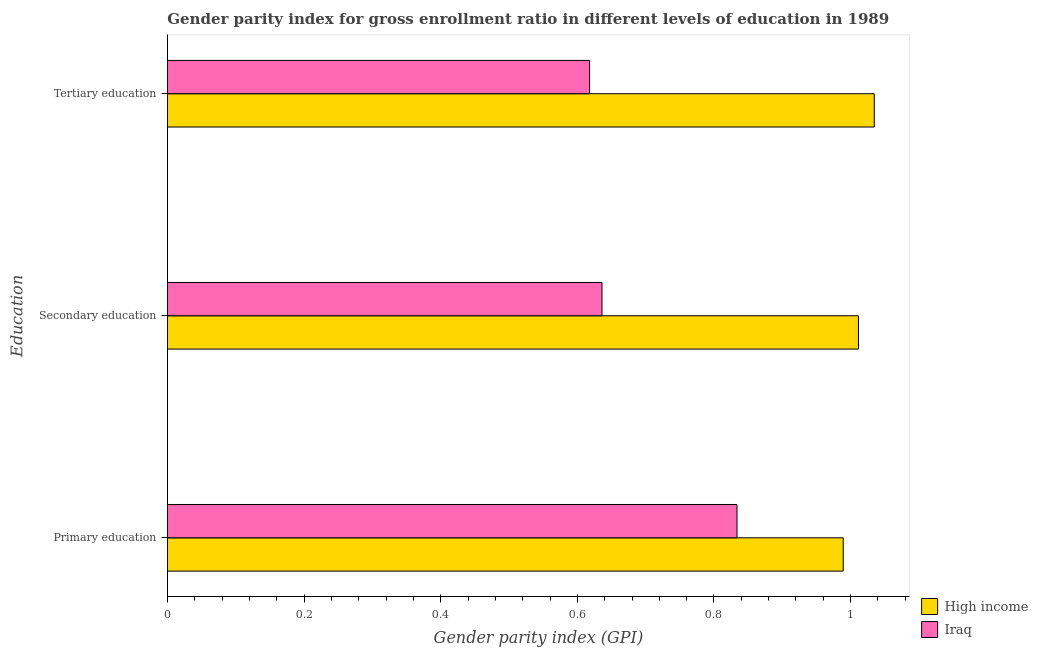How many different coloured bars are there?
Provide a succinct answer. 2. Are the number of bars per tick equal to the number of legend labels?
Offer a very short reply. Yes. How many bars are there on the 3rd tick from the top?
Your answer should be compact. 2. What is the label of the 2nd group of bars from the top?
Your answer should be very brief. Secondary education. What is the gender parity index in tertiary education in High income?
Your response must be concise. 1.03. Across all countries, what is the maximum gender parity index in tertiary education?
Ensure brevity in your answer.  1.03. Across all countries, what is the minimum gender parity index in secondary education?
Make the answer very short. 0.64. In which country was the gender parity index in tertiary education maximum?
Your answer should be very brief. High income. In which country was the gender parity index in tertiary education minimum?
Make the answer very short. Iraq. What is the total gender parity index in primary education in the graph?
Provide a succinct answer. 1.82. What is the difference between the gender parity index in tertiary education in Iraq and that in High income?
Offer a terse response. -0.42. What is the difference between the gender parity index in secondary education in Iraq and the gender parity index in tertiary education in High income?
Offer a terse response. -0.4. What is the average gender parity index in secondary education per country?
Offer a terse response. 0.82. What is the difference between the gender parity index in secondary education and gender parity index in primary education in Iraq?
Ensure brevity in your answer.  -0.2. What is the ratio of the gender parity index in tertiary education in Iraq to that in High income?
Your response must be concise. 0.6. Is the difference between the gender parity index in primary education in High income and Iraq greater than the difference between the gender parity index in tertiary education in High income and Iraq?
Give a very brief answer. No. What is the difference between the highest and the second highest gender parity index in tertiary education?
Offer a very short reply. 0.42. What is the difference between the highest and the lowest gender parity index in primary education?
Your response must be concise. 0.16. Is the sum of the gender parity index in secondary education in High income and Iraq greater than the maximum gender parity index in primary education across all countries?
Make the answer very short. Yes. What does the 1st bar from the top in Primary education represents?
Make the answer very short. Iraq. Are all the bars in the graph horizontal?
Keep it short and to the point. Yes. How many countries are there in the graph?
Give a very brief answer. 2. Does the graph contain any zero values?
Your response must be concise. No. How many legend labels are there?
Offer a terse response. 2. How are the legend labels stacked?
Make the answer very short. Vertical. What is the title of the graph?
Give a very brief answer. Gender parity index for gross enrollment ratio in different levels of education in 1989. What is the label or title of the X-axis?
Offer a terse response. Gender parity index (GPI). What is the label or title of the Y-axis?
Provide a short and direct response. Education. What is the Gender parity index (GPI) in High income in Primary education?
Your answer should be very brief. 0.99. What is the Gender parity index (GPI) of Iraq in Primary education?
Offer a terse response. 0.83. What is the Gender parity index (GPI) in High income in Secondary education?
Provide a succinct answer. 1.01. What is the Gender parity index (GPI) in Iraq in Secondary education?
Ensure brevity in your answer.  0.64. What is the Gender parity index (GPI) of High income in Tertiary education?
Ensure brevity in your answer.  1.03. What is the Gender parity index (GPI) of Iraq in Tertiary education?
Keep it short and to the point. 0.62. Across all Education, what is the maximum Gender parity index (GPI) of High income?
Offer a very short reply. 1.03. Across all Education, what is the maximum Gender parity index (GPI) in Iraq?
Provide a short and direct response. 0.83. Across all Education, what is the minimum Gender parity index (GPI) in High income?
Your answer should be compact. 0.99. Across all Education, what is the minimum Gender parity index (GPI) of Iraq?
Your answer should be compact. 0.62. What is the total Gender parity index (GPI) of High income in the graph?
Provide a succinct answer. 3.04. What is the total Gender parity index (GPI) of Iraq in the graph?
Your response must be concise. 2.09. What is the difference between the Gender parity index (GPI) of High income in Primary education and that in Secondary education?
Offer a terse response. -0.02. What is the difference between the Gender parity index (GPI) in Iraq in Primary education and that in Secondary education?
Provide a succinct answer. 0.2. What is the difference between the Gender parity index (GPI) of High income in Primary education and that in Tertiary education?
Offer a terse response. -0.05. What is the difference between the Gender parity index (GPI) in Iraq in Primary education and that in Tertiary education?
Offer a very short reply. 0.22. What is the difference between the Gender parity index (GPI) in High income in Secondary education and that in Tertiary education?
Give a very brief answer. -0.02. What is the difference between the Gender parity index (GPI) of Iraq in Secondary education and that in Tertiary education?
Your answer should be very brief. 0.02. What is the difference between the Gender parity index (GPI) of High income in Primary education and the Gender parity index (GPI) of Iraq in Secondary education?
Ensure brevity in your answer.  0.35. What is the difference between the Gender parity index (GPI) in High income in Primary education and the Gender parity index (GPI) in Iraq in Tertiary education?
Provide a short and direct response. 0.37. What is the difference between the Gender parity index (GPI) of High income in Secondary education and the Gender parity index (GPI) of Iraq in Tertiary education?
Provide a short and direct response. 0.39. What is the average Gender parity index (GPI) in High income per Education?
Provide a succinct answer. 1.01. What is the average Gender parity index (GPI) in Iraq per Education?
Make the answer very short. 0.7. What is the difference between the Gender parity index (GPI) of High income and Gender parity index (GPI) of Iraq in Primary education?
Make the answer very short. 0.16. What is the difference between the Gender parity index (GPI) of High income and Gender parity index (GPI) of Iraq in Secondary education?
Keep it short and to the point. 0.38. What is the difference between the Gender parity index (GPI) of High income and Gender parity index (GPI) of Iraq in Tertiary education?
Your answer should be compact. 0.42. What is the ratio of the Gender parity index (GPI) in High income in Primary education to that in Secondary education?
Ensure brevity in your answer.  0.98. What is the ratio of the Gender parity index (GPI) of Iraq in Primary education to that in Secondary education?
Your answer should be very brief. 1.31. What is the ratio of the Gender parity index (GPI) of High income in Primary education to that in Tertiary education?
Your response must be concise. 0.96. What is the ratio of the Gender parity index (GPI) of Iraq in Primary education to that in Tertiary education?
Offer a terse response. 1.35. What is the ratio of the Gender parity index (GPI) in High income in Secondary education to that in Tertiary education?
Your answer should be compact. 0.98. What is the ratio of the Gender parity index (GPI) of Iraq in Secondary education to that in Tertiary education?
Provide a succinct answer. 1.03. What is the difference between the highest and the second highest Gender parity index (GPI) in High income?
Make the answer very short. 0.02. What is the difference between the highest and the second highest Gender parity index (GPI) of Iraq?
Ensure brevity in your answer.  0.2. What is the difference between the highest and the lowest Gender parity index (GPI) of High income?
Provide a short and direct response. 0.05. What is the difference between the highest and the lowest Gender parity index (GPI) in Iraq?
Keep it short and to the point. 0.22. 